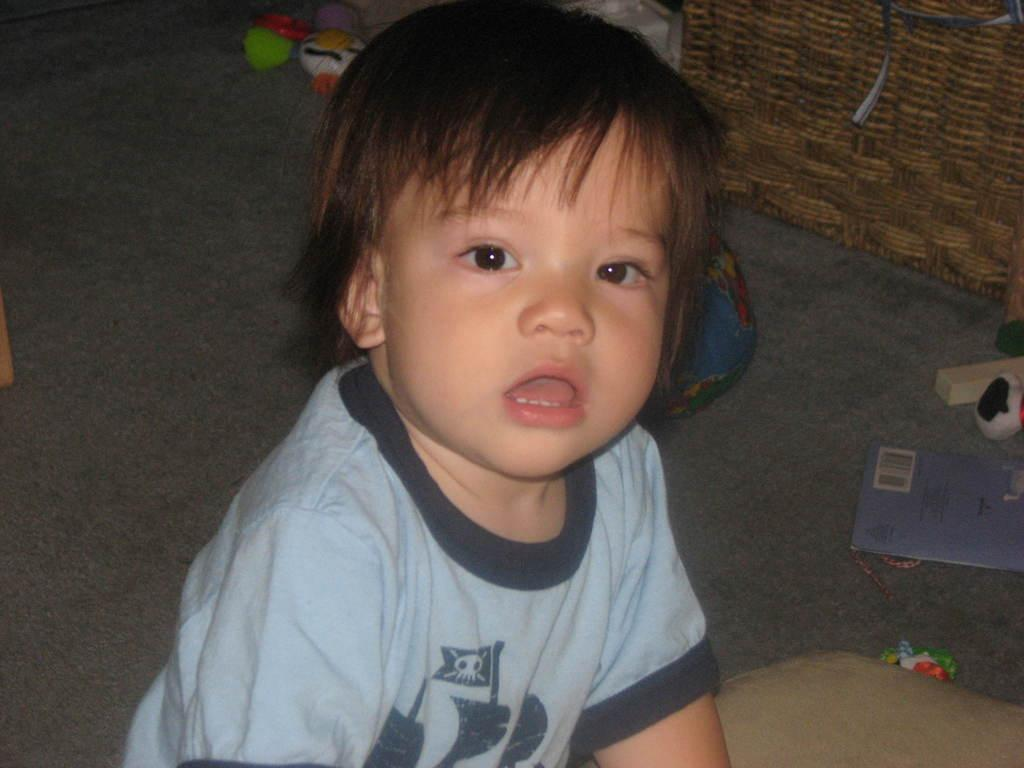What is the main subject of the picture? The main subject of the picture is a kid in the center. What can be seen on the right side of the picture? There are toys, a book, and a basket on the right side of the picture. Are there any toys visible in a different part of the image? Yes, there are toys at the top of the picture. What is the object on the left side of the picture? There is an object on the left side of the picture, and it is on the floor. How many chickens are present in the picture? There are no chickens present in the picture. What type of plant can be seen growing near the toys? There is no plant visible in the picture. 